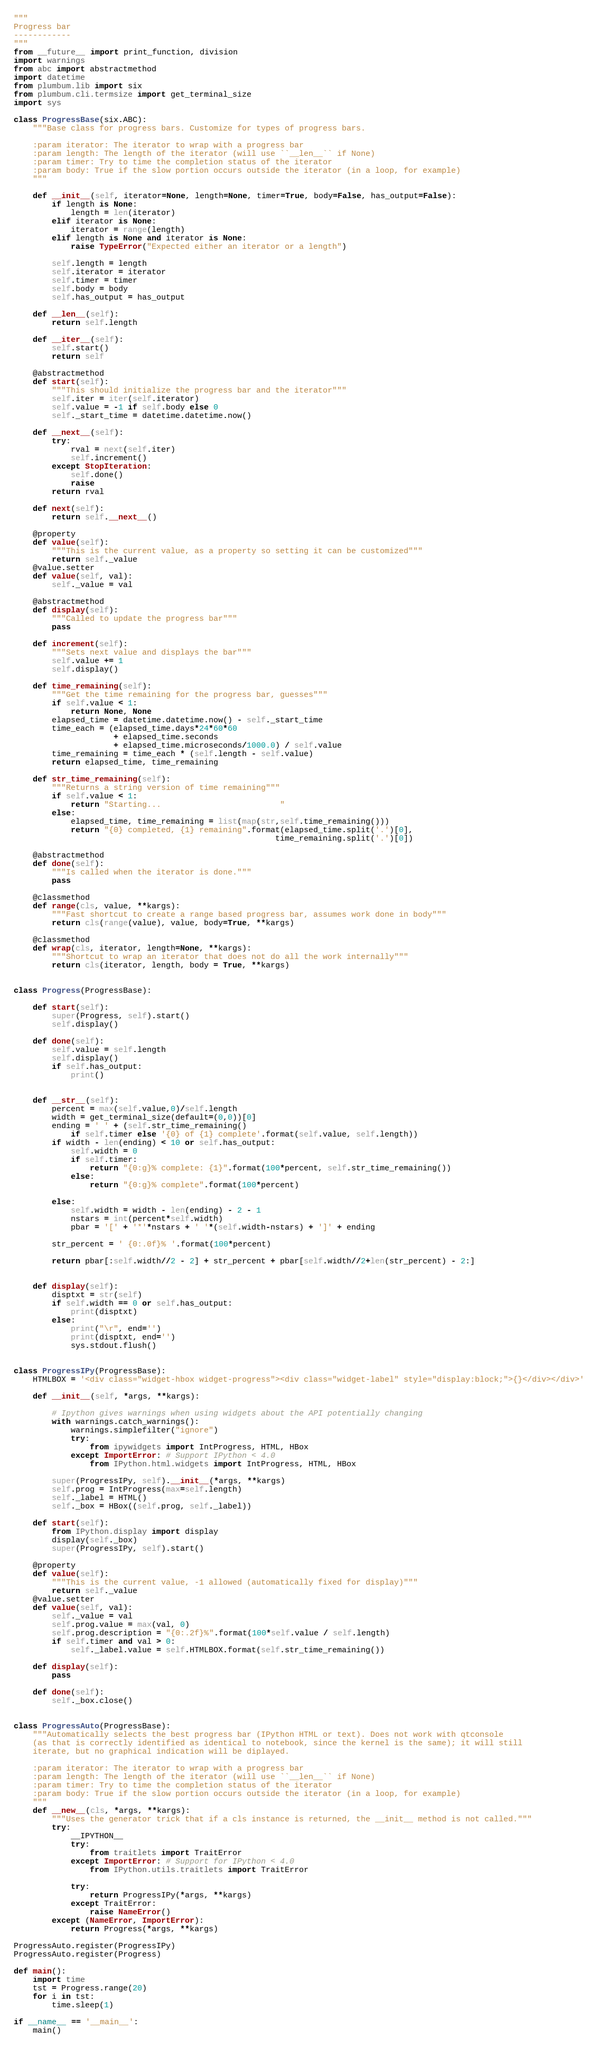Convert code to text. <code><loc_0><loc_0><loc_500><loc_500><_Python_>"""
Progress bar
------------
"""
from __future__ import print_function, division
import warnings
from abc import abstractmethod
import datetime
from plumbum.lib import six
from plumbum.cli.termsize import get_terminal_size
import sys

class ProgressBase(six.ABC):
    """Base class for progress bars. Customize for types of progress bars.

    :param iterator: The iterator to wrap with a progress bar
    :param length: The length of the iterator (will use ``__len__`` if None)
    :param timer: Try to time the completion status of the iterator
    :param body: True if the slow portion occurs outside the iterator (in a loop, for example)
    """

    def __init__(self, iterator=None, length=None, timer=True, body=False, has_output=False):
        if length is None:
            length = len(iterator)
        elif iterator is None:
            iterator = range(length)
        elif length is None and iterator is None:
            raise TypeError("Expected either an iterator or a length")

        self.length = length
        self.iterator = iterator
        self.timer = timer
        self.body = body
        self.has_output = has_output

    def __len__(self):
        return self.length

    def __iter__(self):
        self.start()
        return self

    @abstractmethod
    def start(self):
        """This should initialize the progress bar and the iterator"""
        self.iter = iter(self.iterator)
        self.value = -1 if self.body else 0
        self._start_time = datetime.datetime.now()

    def __next__(self):
        try:
            rval = next(self.iter)
            self.increment()
        except StopIteration:
            self.done()
            raise
        return rval

    def next(self):
        return self.__next__()

    @property
    def value(self):
        """This is the current value, as a property so setting it can be customized"""
        return self._value
    @value.setter
    def value(self, val):
        self._value = val

    @abstractmethod
    def display(self):
        """Called to update the progress bar"""
        pass

    def increment(self):
        """Sets next value and displays the bar"""
        self.value += 1
        self.display()

    def time_remaining(self):
        """Get the time remaining for the progress bar, guesses"""
        if self.value < 1:
            return None, None
        elapsed_time = datetime.datetime.now() - self._start_time
        time_each = (elapsed_time.days*24*60*60
                     + elapsed_time.seconds
                     + elapsed_time.microseconds/1000.0) / self.value
        time_remaining = time_each * (self.length - self.value)
        return elapsed_time, time_remaining

    def str_time_remaining(self):
        """Returns a string version of time remaining"""
        if self.value < 1:
            return "Starting...                         "
        else:
            elapsed_time, time_remaining = list(map(str,self.time_remaining()))
            return "{0} completed, {1} remaining".format(elapsed_time.split('.')[0],
                                                       time_remaining.split('.')[0])

    @abstractmethod
    def done(self):
        """Is called when the iterator is done."""
        pass

    @classmethod
    def range(cls, value, **kargs):
        """Fast shortcut to create a range based progress bar, assumes work done in body"""
        return cls(range(value), value, body=True, **kargs)

    @classmethod
    def wrap(cls, iterator, length=None, **kargs):
        """Shortcut to wrap an iterator that does not do all the work internally"""
        return cls(iterator, length, body = True, **kargs)


class Progress(ProgressBase):

    def start(self):
        super(Progress, self).start()
        self.display()

    def done(self):
        self.value = self.length
        self.display()
        if self.has_output:
            print()


    def __str__(self):
        percent = max(self.value,0)/self.length
        width = get_terminal_size(default=(0,0))[0]
        ending = ' ' + (self.str_time_remaining()
            if self.timer else '{0} of {1} complete'.format(self.value, self.length))
        if width - len(ending) < 10 or self.has_output:
            self.width = 0
            if self.timer:
                return "{0:g}% complete: {1}".format(100*percent, self.str_time_remaining())
            else:
                return "{0:g}% complete".format(100*percent)

        else:
            self.width = width - len(ending) - 2 - 1
            nstars = int(percent*self.width)
            pbar = '[' + '*'*nstars + ' '*(self.width-nstars) + ']' + ending

        str_percent = ' {0:.0f}% '.format(100*percent)

        return pbar[:self.width//2 - 2] + str_percent + pbar[self.width//2+len(str_percent) - 2:]


    def display(self):
        disptxt = str(self)
        if self.width == 0 or self.has_output:
            print(disptxt)
        else:
            print("\r", end='')
            print(disptxt, end='')
            sys.stdout.flush()


class ProgressIPy(ProgressBase):
    HTMLBOX = '<div class="widget-hbox widget-progress"><div class="widget-label" style="display:block;">{}</div></div>'

    def __init__(self, *args, **kargs):

        # Ipython gives warnings when using widgets about the API potentially changing
        with warnings.catch_warnings():
            warnings.simplefilter("ignore")
            try:
                from ipywidgets import IntProgress, HTML, HBox
            except ImportError: # Support IPython < 4.0
                from IPython.html.widgets import IntProgress, HTML, HBox

        super(ProgressIPy, self).__init__(*args, **kargs)
        self.prog = IntProgress(max=self.length)
        self._label = HTML()
        self._box = HBox((self.prog, self._label))

    def start(self):
        from IPython.display import display
        display(self._box)
        super(ProgressIPy, self).start()

    @property
    def value(self):
        """This is the current value, -1 allowed (automatically fixed for display)"""
        return self._value
    @value.setter
    def value(self, val):
        self._value = val
        self.prog.value = max(val, 0)
        self.prog.description = "{0:.2f}%".format(100*self.value / self.length)
        if self.timer and val > 0:
            self._label.value = self.HTMLBOX.format(self.str_time_remaining())

    def display(self):
        pass

    def done(self):
        self._box.close()


class ProgressAuto(ProgressBase):
    """Automatically selects the best progress bar (IPython HTML or text). Does not work with qtconsole
    (as that is correctly identified as identical to notebook, since the kernel is the same); it will still
    iterate, but no graphical indication will be diplayed.

    :param iterator: The iterator to wrap with a progress bar
    :param length: The length of the iterator (will use ``__len__`` if None)
    :param timer: Try to time the completion status of the iterator
    :param body: True if the slow portion occurs outside the iterator (in a loop, for example)
    """
    def __new__(cls, *args, **kargs):
        """Uses the generator trick that if a cls instance is returned, the __init__ method is not called."""
        try:
            __IPYTHON__
            try:
                from traitlets import TraitError
            except ImportError: # Support for IPython < 4.0
                from IPython.utils.traitlets import TraitError

            try:
                return ProgressIPy(*args, **kargs)
            except TraitError:
                raise NameError()
        except (NameError, ImportError):
            return Progress(*args, **kargs)

ProgressAuto.register(ProgressIPy)
ProgressAuto.register(Progress)

def main():
    import time
    tst = Progress.range(20)
    for i in tst:
        time.sleep(1)

if __name__ == '__main__':
    main()
</code> 